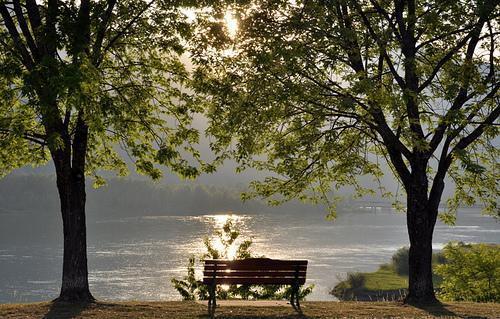How many trees are in the image?
Give a very brief answer. 2. 